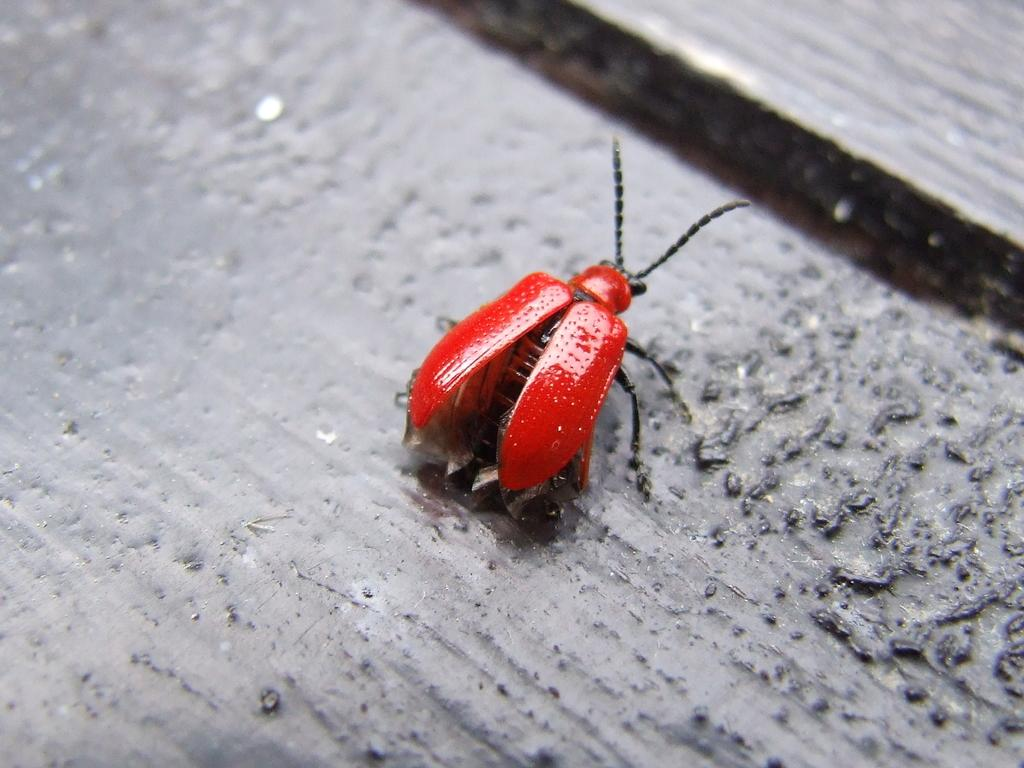What is present on the floor in the image? There is a bug in the image. What color is the bug? The bug is red in color. What type of laughter can be heard coming from the bug in the image? There is no laughter present in the image, as bugs do not have the ability to laugh. 